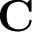<formula> <loc_0><loc_0><loc_500><loc_500>C</formula> 